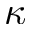<formula> <loc_0><loc_0><loc_500><loc_500>\kappa</formula> 